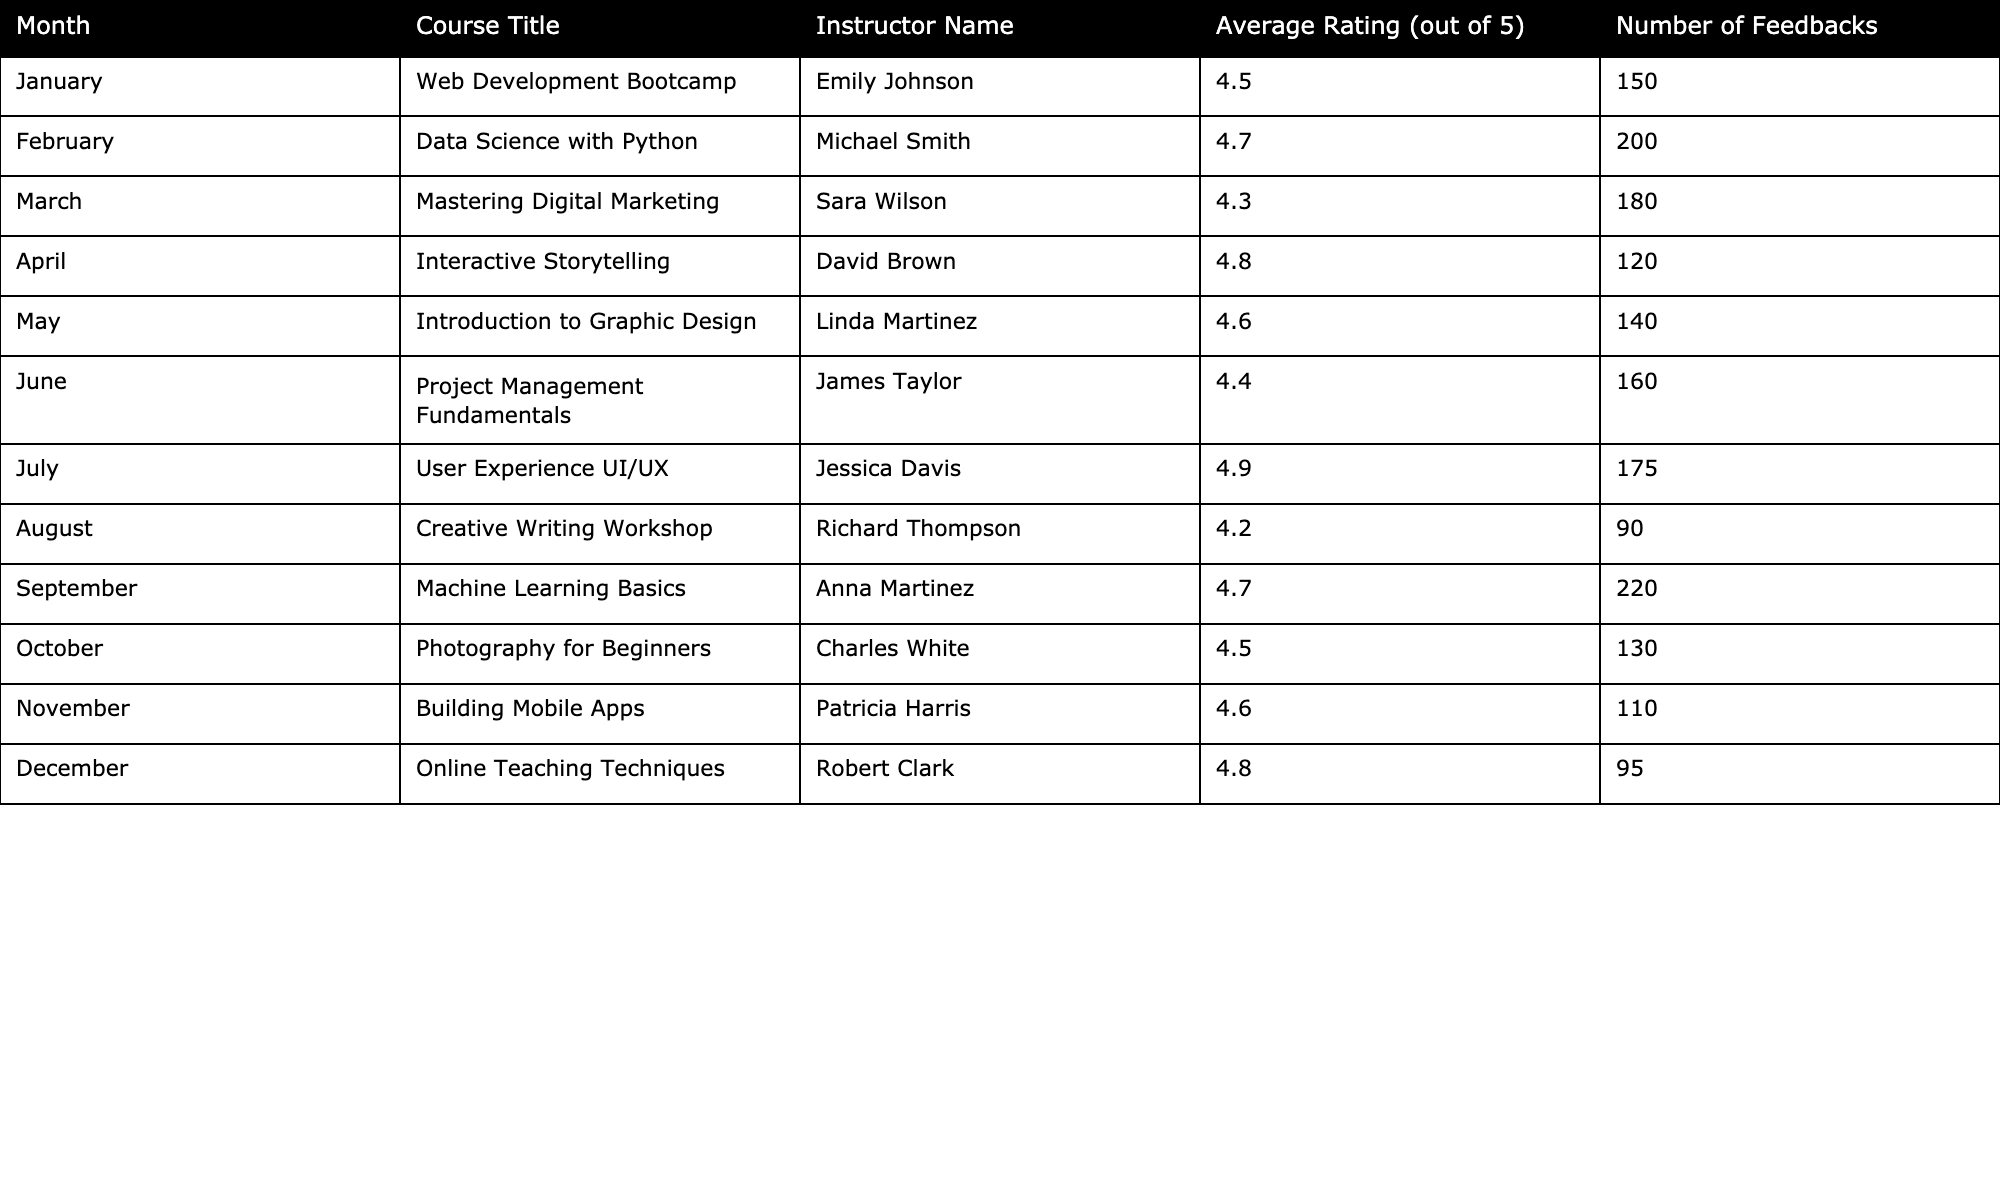What is the average rating for the course "User Experience UI/UX"? The rating for "User Experience UI/UX" is 4.9 as listed in the table.
Answer: 4.9 How many feedbacks were received for the course "Data Science with Python"? The number of feedbacks for "Data Science with Python" is 200 according to the table.
Answer: 200 What is the title of the course with the highest average rating? The course with the highest average rating is "User Experience UI/UX" with a rating of 4.9.
Answer: User Experience UI/UX Which month had the least number of feedbacks? The month with the least number of feedbacks is August, with only 90 feedbacks received for the "Creative Writing Workshop."
Answer: August What is the difference in average ratings between "Mastering Digital Marketing" and "Introduction to Graphic Design"? "Mastering Digital Marketing" has a rating of 4.3 and "Introduction to Graphic Design" has a rating of 4.6. The difference is 4.6 - 4.3 = 0.3.
Answer: 0.3 Did any course receive more than 200 feedbacks? Yes, the course "Machine Learning Basics" received 220 feedbacks, which is over 200.
Answer: Yes What is the average rating of the courses overall? The average rating is calculated by adding all the ratings (4.5 + 4.7 + 4.3 + 4.8 + 4.6 + 4.4 + 4.9 + 4.2 + 4.7 + 4.5 + 4.6 + 4.8 = 54.6) and dividing by the number of courses (12), resulting in an average of approximately 4.55.
Answer: 4.55 How many courses have an average rating of 4.6 or higher? There are 7 courses with an average rating of 4.6 or higher: "Web Development Bootcamp," "Data Science with Python," "Interactive Storytelling," "Introduction to Graphic Design," "User Experience UI/UX," "Building Mobile Apps," and "Online Teaching Techniques."
Answer: 7 Which instructor taught the course that had the highest number of feedbacks? The course with the highest number of feedbacks, "Machine Learning Basics," was taught by Anna Martinez, with 220 feedbacks.
Answer: Anna Martinez What percentage of total feedbacks does "Creative Writing Workshop" represent? The total number of feedbacks across all courses is 1,495. "Creative Writing Workshop" received 90 feedbacks. Therefore, the percentage is (90 / 1495) * 100 ≈ 6.02%.
Answer: 6.02% 